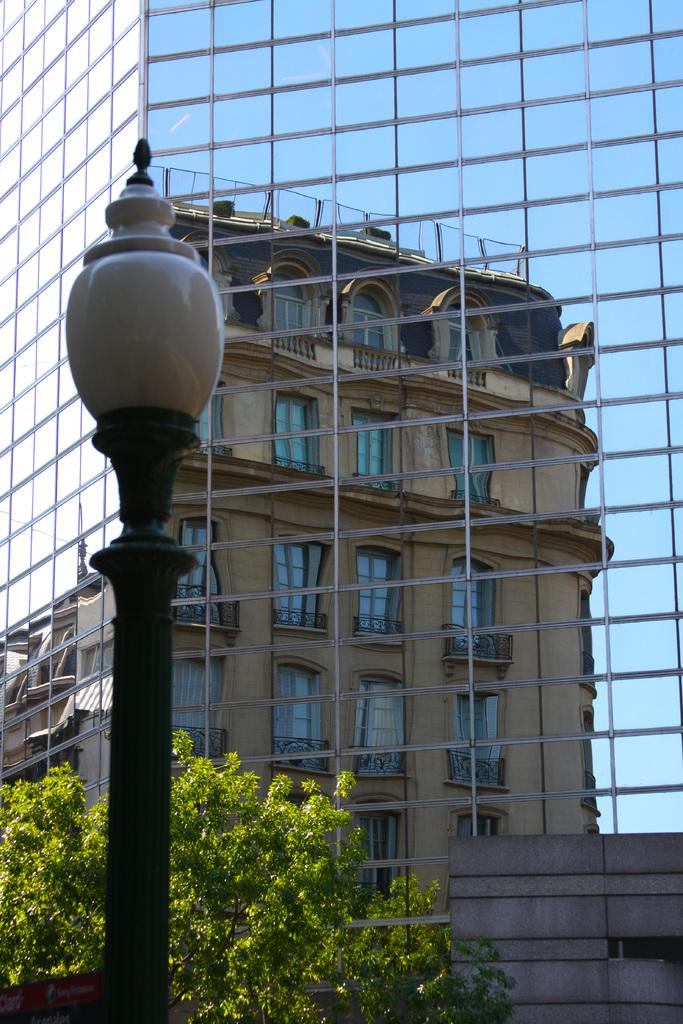What type of building is shown in the image? There is a glass building in the image. What feature of the building is made of glass? The building has glass windows. What can be seen in front of the building? There is a white and black color pole in front of the building. What type of natural elements are visible in the image? Trees are visible in the image. Where is the grandfather sitting in the image? There is no grandfather present in the image. What type of box is used to store the building in the image? The building is not stored in a box; it is a physical structure. 